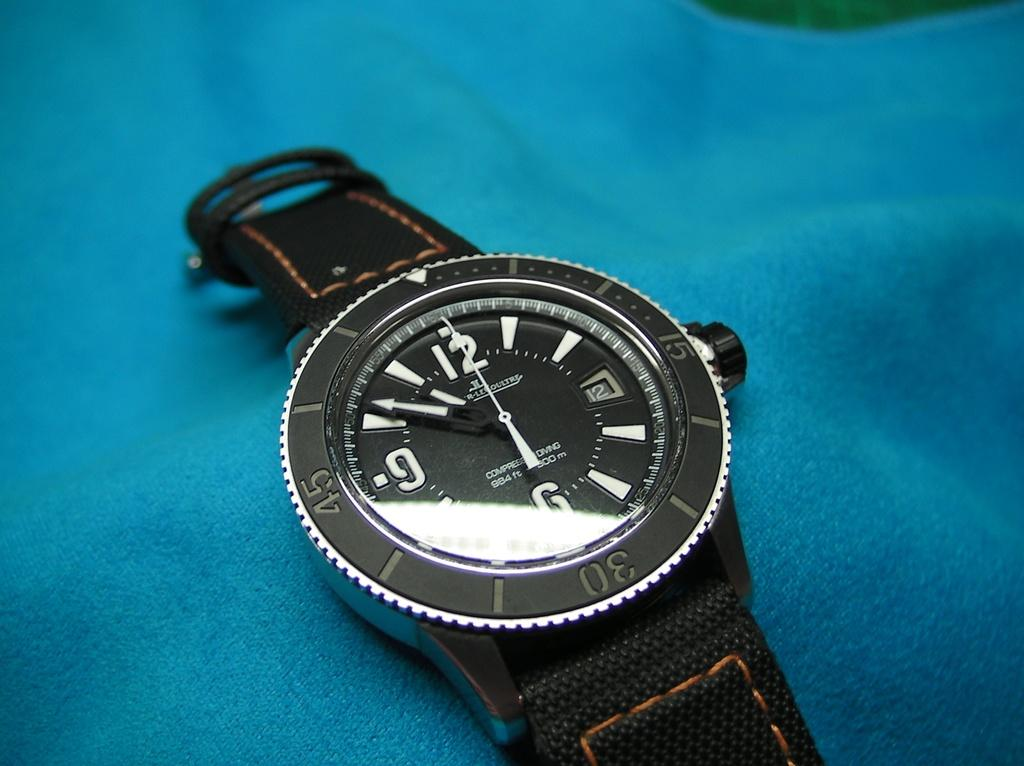<image>
Share a concise interpretation of the image provided. A black watch has the text "984 ft" on it's black face. 